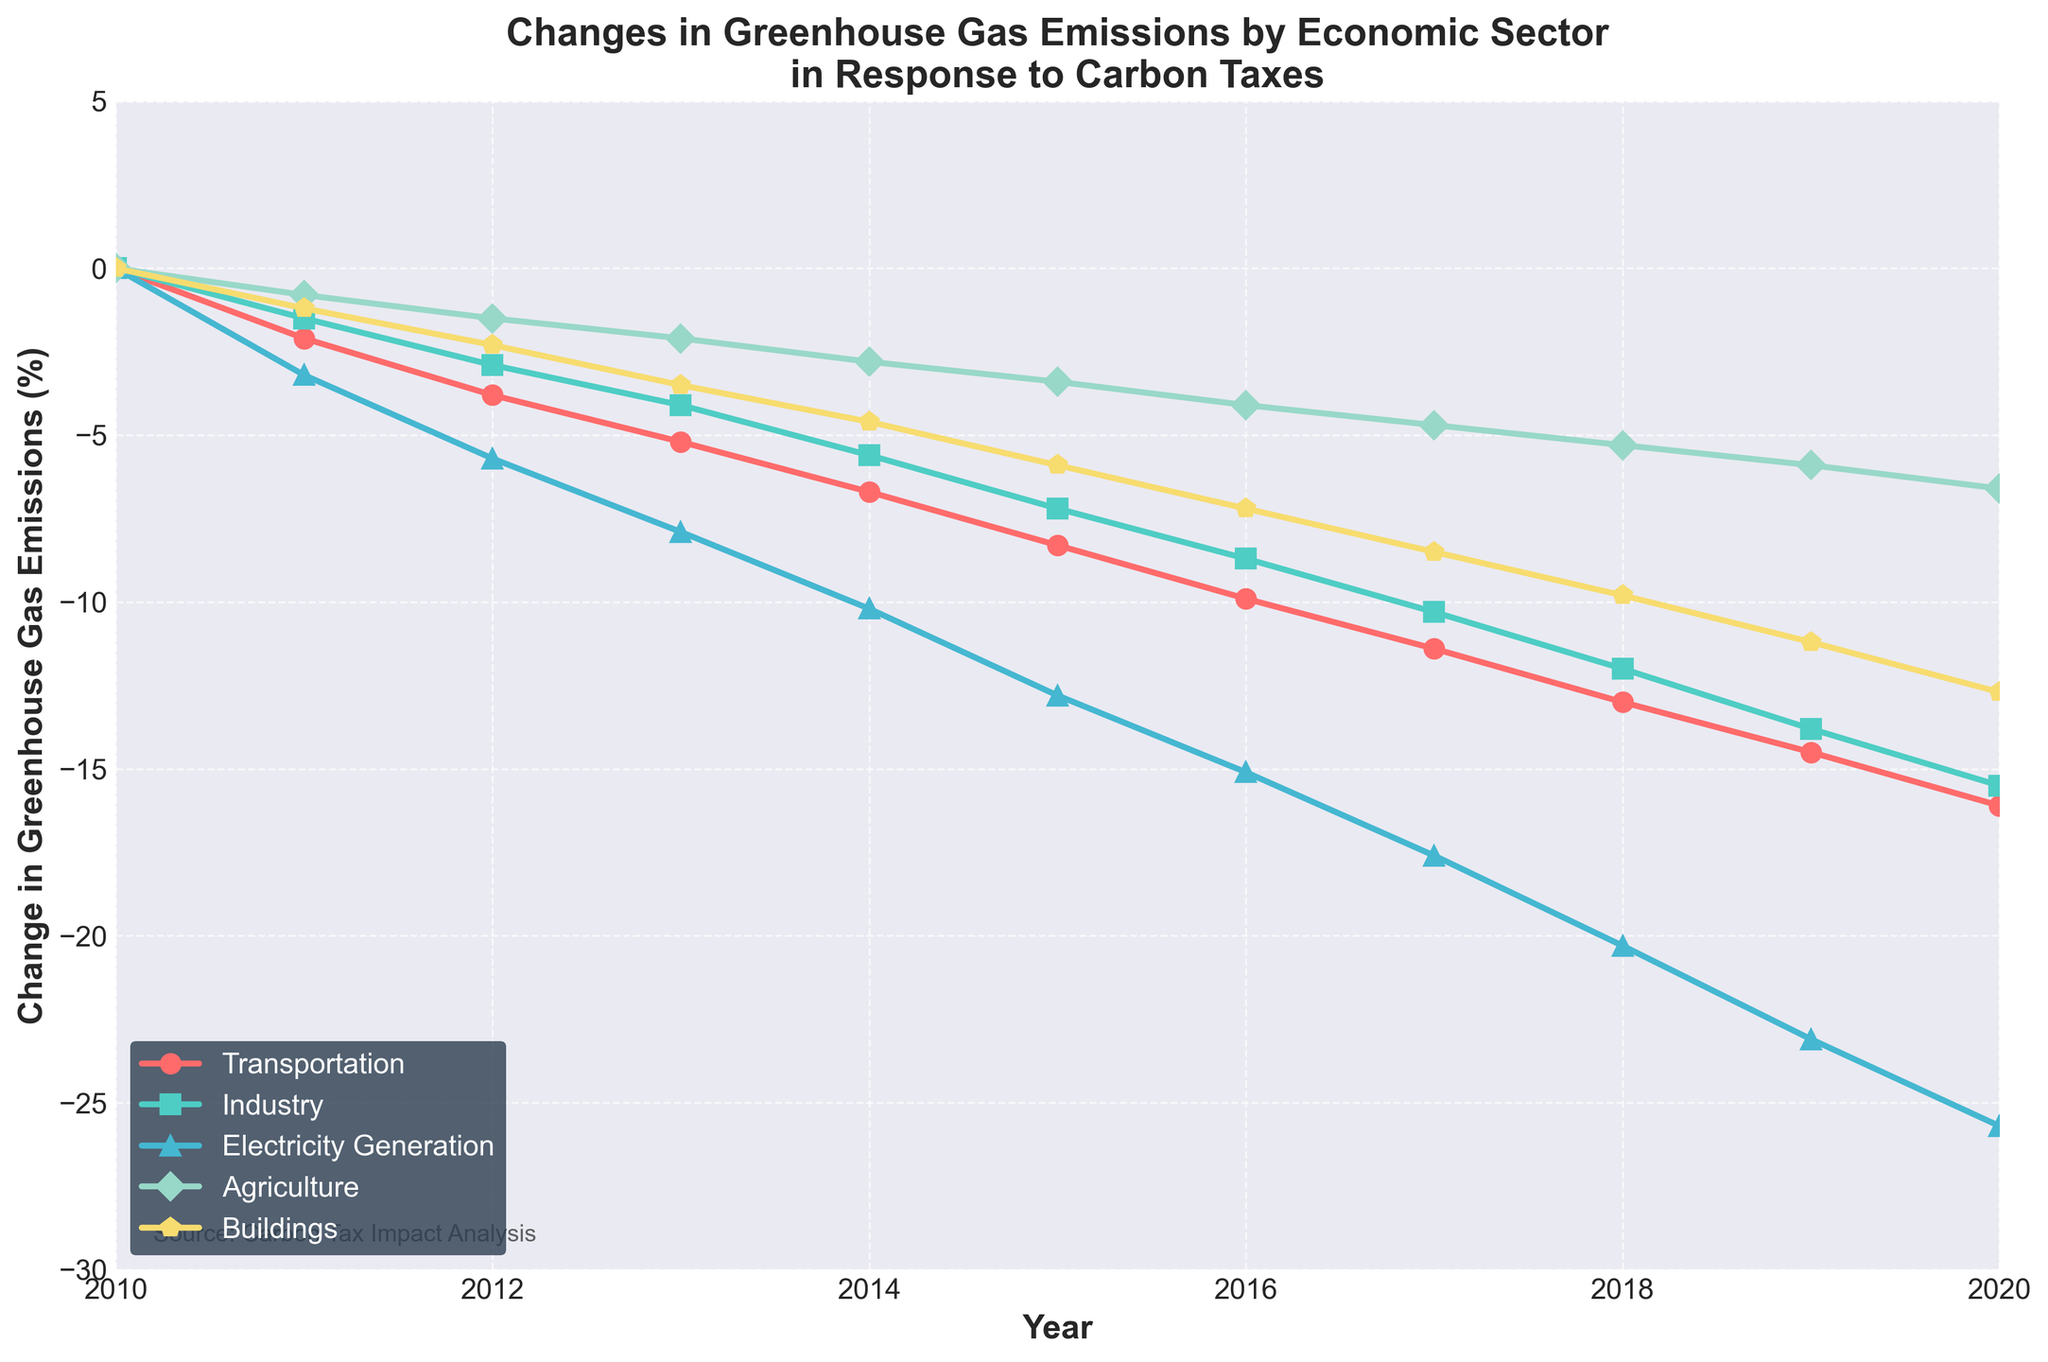What sector experienced the largest decrease in greenhouse gas emissions by 2020? Identify the sector with the steepest decline in the data by visually assessing the endpoints of the lines. The "Electricity Generation" sector shows the largest decrease by reaching -25.7%.
Answer: Electricity Generation How much did greenhouse gas emissions from the Agriculture sector change between 2010 and 2015? From the graph, find the values for the Agriculture sector in 2010 (0%) and 2015 (-3.4%). Subtract the 2010 value from the 2015 value to find the difference: -3.4% - 0% = -3.4%.
Answer: -3.4% Which two sectors showed the closest greenhouse gas emissions changes in 2013? Look at the specific points for each sector in the year 2013 and compare them. The Industry sector (-4.1%) and the Agriculture sector (-2.1%) are the closest to each other.
Answer: Industry and Agriculture By how much did the Transportation sector's emissions decrease on average per year from 2010 to 2020? Calculate the overall change for the Transportation sector from 2010 to 2020: -16.1% - 0% = -16.1%. Then, divide this change by the number of years (2020-2010 = 10 years): -16.1% / 10 = -1.61%.
Answer: -1.61% per year What year did the Buildings sector experience a greater decrease in emissions than the Industry sector for the first time? Examine the annual decrease percentages for each sector and find the first year when the Buildings sector decrease surpasses that of the Industry sector. By 2020, the Buildings sector decrease (-12.7%) is larger than the Industry sector decrease (-15.5%), but the first instance is in 2016 when Buildings (-7.2%) is slightly above Industry (-8.7%).
Answer: 2016 How does the rate of emission reduction for 'Electricity Generation' from 2015 to 2020 compare to that from 2010 to 2015? Calculate the annual average reduction rate for both periods: For 2010-2015, the total reduction is 0% to -12.8%, equaling -12.8% over 5 years (-12.8% / 5 = -2.56% per year). For 2015-2020, it's -12.8% to -25.7%, equaling -12.9% over 5 years (-12.9% / 5 = -2.58% per year). Compare -2.56% to -2.58% per year.
Answer: Slightly faster from 2015 to 2020 At what years did the Transportation sector see a reduction of at least 10% in emissions from the 2010 levels? Find the data points on the graph where the Transportation sector line crosses -10%. According to the plot, it happens between 2017 and 2018.
Answer: 2018 Which sector exhibited the most consistent reduction in greenhouse gas emissions throughout the decade? Identify the sector with the smoothest and most uniform slope throughout the years from 2010 to 2020. "Transport" and "Electricity Generation" show very consistent reductions. Given the provided sectors, the "Electricity Generation" sector indicates the most steady and predictable pattern.
Answer: Electricity Generation 